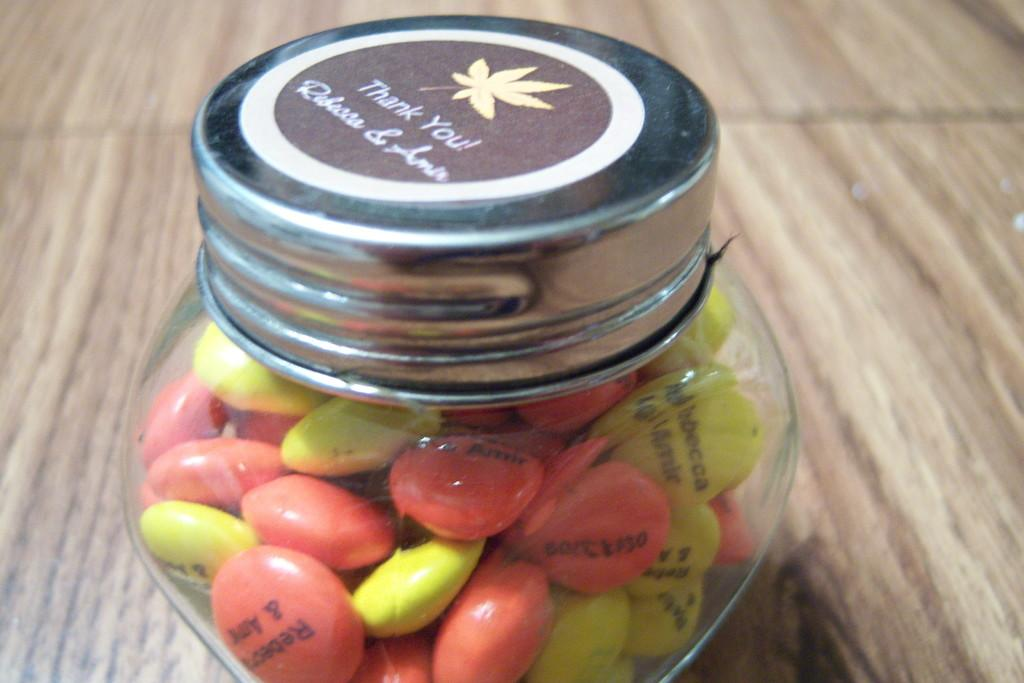Where was the image taken? The image is taken indoors. What furniture is present in the image? There is a table in the image. What items can be seen on the table? There is a bottle of candies on the table. What type of ice can be seen melting on the table in the image? There is no ice present in the image; it features a bottle of candies on the table. How many people are involved in the cooking process in the image? There is no cooking process depicted in the image; it only shows a table with a bottle of candies. 